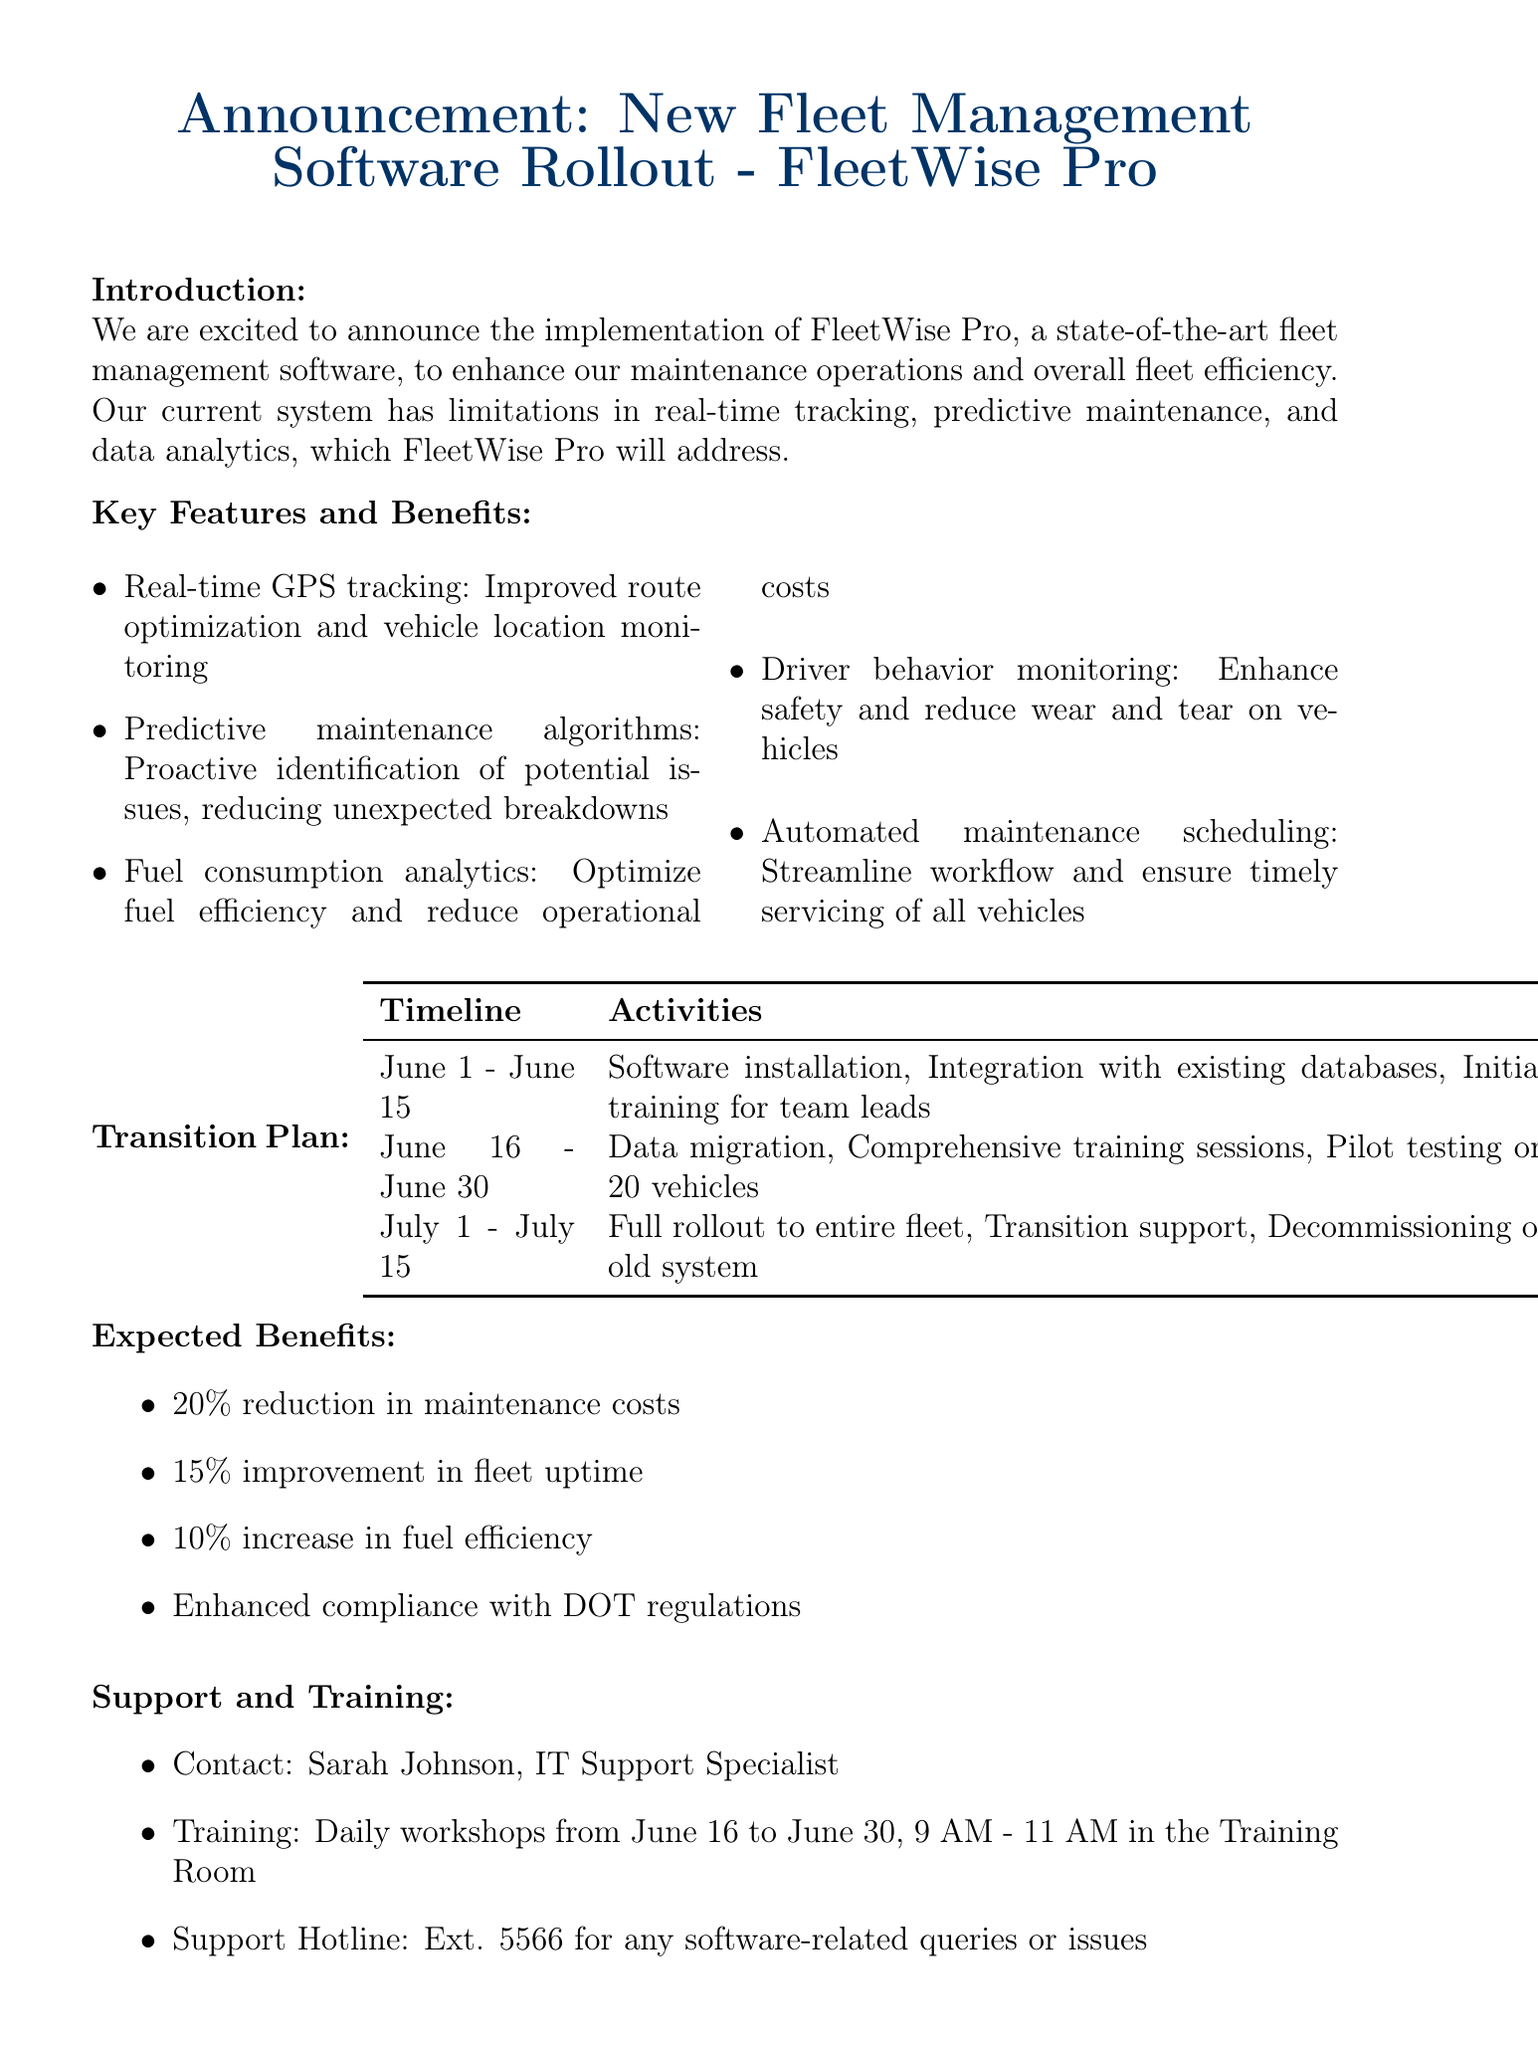What is the name of the new software being rolled out? The document states that the new software is called FleetWise Pro.
Answer: FleetWise Pro What are the three phases of the transition plan? The transition plan outlines three phases: installation and training, data migration and testing, and full rollout and support.
Answer: Phase 1, Phase 2, Phase 3 When is the full rollout scheduled to occur? The full rollout is planned for July 1 to July 15.
Answer: July 1 - July 15 What type of analytics will be improved with the new software? The document mentions that fuel consumption analytics will be improved to optimize fuel efficiency.
Answer: Fuel consumption analytics Who is the contact person for support related to the new software? The memo indicates that Sarah Johnson is the contact person for IT support.
Answer: Sarah Johnson What is one expected benefit of implementing FleetWise Pro? The implementation of FleetWise Pro is expected to reduce maintenance costs by 20%.
Answer: 20% reduction in maintenance costs What kind of monitoring feature does the software include? The software includes driver behavior monitoring to enhance safety.
Answer: Driver behavior monitoring What days and time are training sessions scheduled? The training sessions are scheduled daily from June 16 to June 30, 9 AM to 11 AM.
Answer: Daily from June 16 to June 30, 9 AM - 11 AM What is the hotline extension for any software-related queries? The document provides the support hotline extension as 5566.
Answer: Ext. 5566 